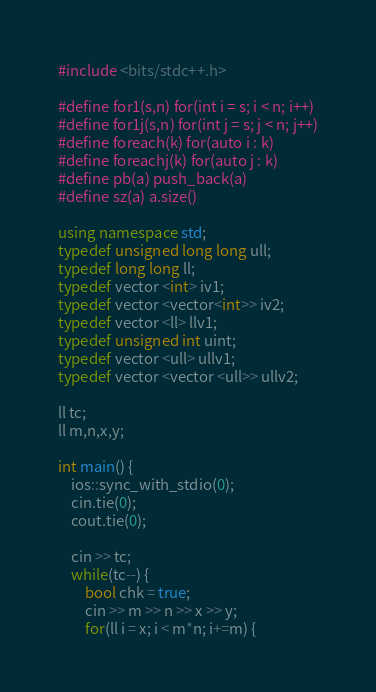Convert code to text. <code><loc_0><loc_0><loc_500><loc_500><_C++_>#include <bits/stdc++.h>

#define for1(s,n) for(int i = s; i < n; i++)
#define for1j(s,n) for(int j = s; j < n; j++)
#define foreach(k) for(auto i : k)
#define foreachj(k) for(auto j : k)
#define pb(a) push_back(a)
#define sz(a) a.size()

using namespace std;
typedef unsigned long long ull;
typedef long long ll;
typedef vector <int> iv1;
typedef vector <vector<int>> iv2;
typedef vector <ll> llv1;
typedef unsigned int uint;
typedef vector <ull> ullv1;
typedef vector <vector <ull>> ullv2;

ll tc;
ll m,n,x,y;

int main() {
    ios::sync_with_stdio(0);
    cin.tie(0);
    cout.tie(0);
    
    cin >> tc;
    while(tc--) {
        bool chk = true;
        cin >> m >> n >> x >> y;
        for(ll i = x; i < m*n; i+=m) {</code> 